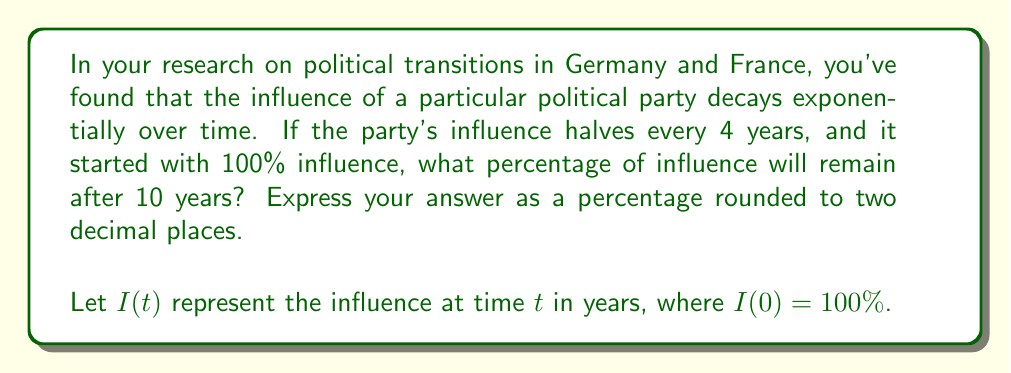Can you answer this question? To solve this problem, we'll use the exponential decay formula and the properties of logarithms:

1) The half-life formula is:
   $I(t) = I(0) \cdot (\frac{1}{2})^{\frac{t}{h}}$
   where $h$ is the half-life (4 years in this case).

2) We need to find $I(10)$:
   $I(10) = 100 \cdot (\frac{1}{2})^{\frac{10}{4}}$

3) Simplify the exponent:
   $I(10) = 100 \cdot (\frac{1}{2})^{2.5}$

4) Calculate:
   $I(10) = 100 \cdot (0.5)^{2.5}$
   $I(10) = 100 \cdot 0.1767766952966369$
   $I(10) = 17.67766952966369$

5) Round to two decimal places:
   $I(10) \approx 17.68\%$

Thus, after 10 years, approximately 17.68% of the party's original influence will remain.
Answer: 17.68% 